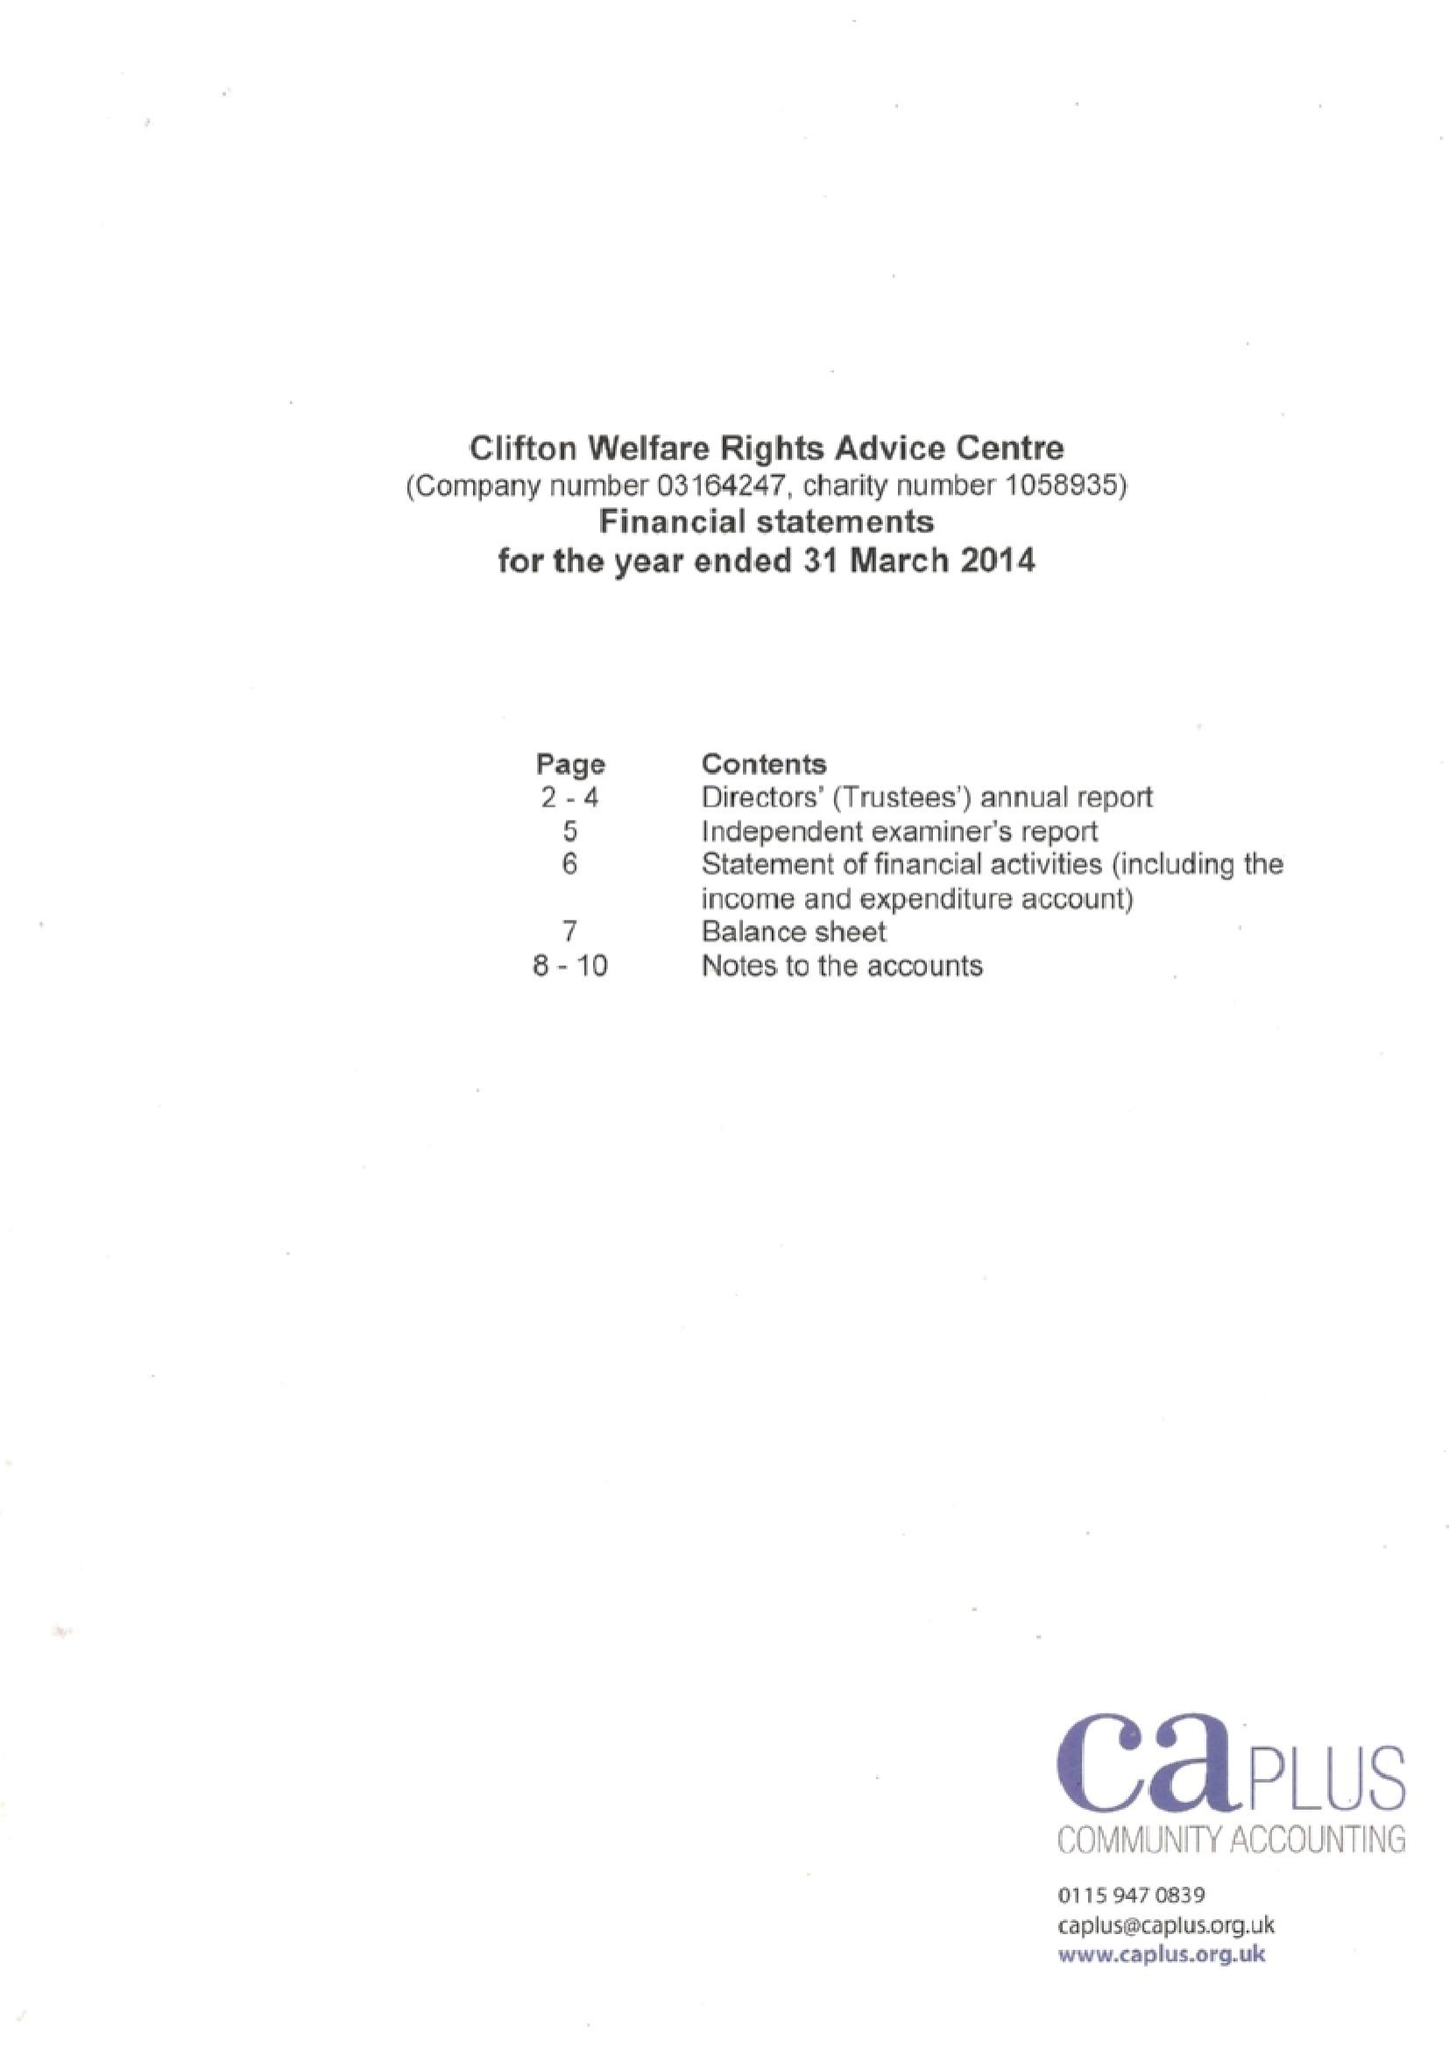What is the value for the report_date?
Answer the question using a single word or phrase. 2014-03-31 